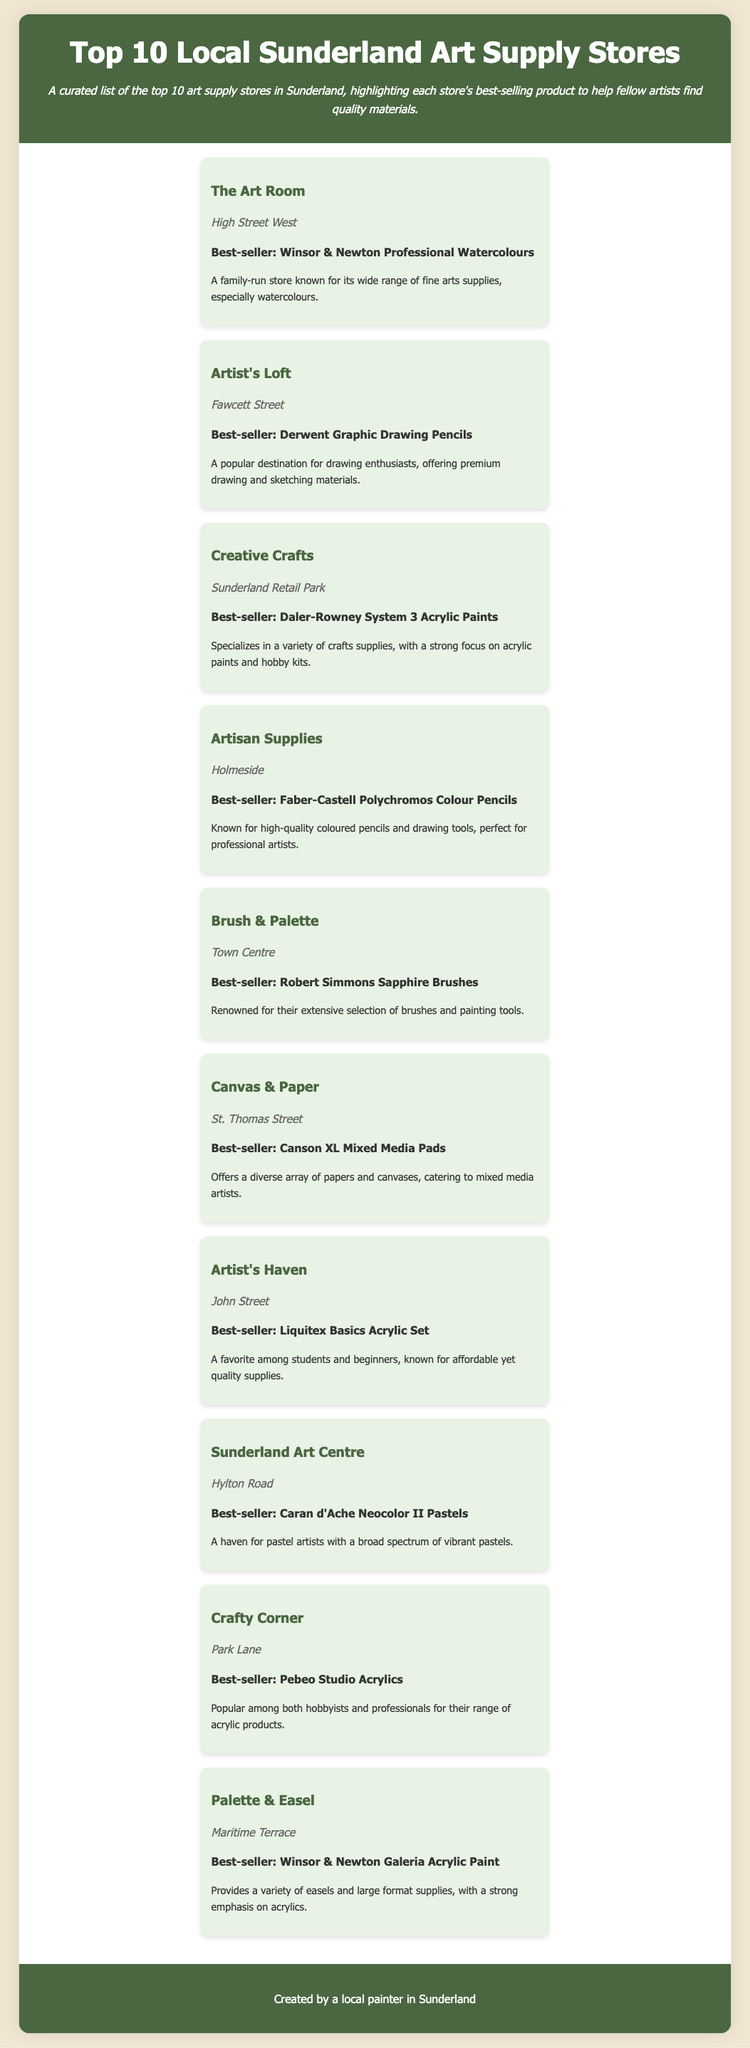What is the name of the first store listed? The first store listed is mentioned at the top of the store list section.
Answer: The Art Room What is the best-selling product at Artist's Loft? The document states the best-selling product for each store in the corresponding paragraph.
Answer: Derwent Graphic Drawing Pencils How many stores are located on Fawcett Street? The document provides locations for each store, and only one store is listed as being on Fawcett Street.
Answer: One Which store is known for its watercolours? The description for each store gives insight into their specialties, particularly highlighting watercolours for one store.
Answer: The Art Room Name one store that sells acrylic paints. The document specifies several stores with their best-selling products, including those that focus on acrylic paints.
Answer: Creative Crafts What type of supply is Palette & Easel known for? Each store’s description includes the types of supplies they are particularly known for, with Palette & Easel emphasizing a specific type.
Answer: Acrylics Which store is referred to as a haven for pastel artists? The document indicates specific stores that cater to different types of artists, including pastels.
Answer: Sunderland Art Centre What is the best-selling product at Canvas & Paper? Each store highlights their best-selling product in the list, providing specific information on what they sell.
Answer: Canson XL Mixed Media Pads How many stores are listed in this infographic? The document clearly states that there are ten stores featured in the list.
Answer: Ten 